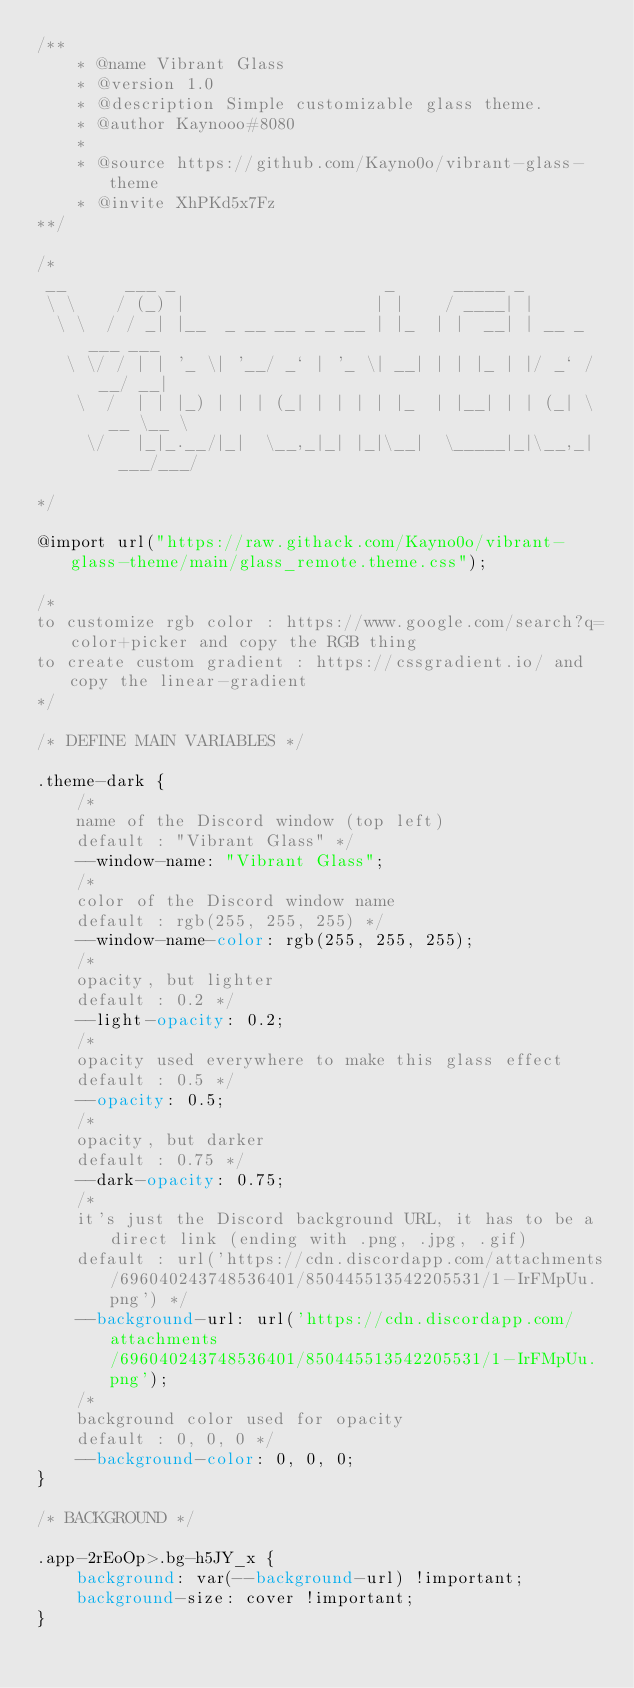<code> <loc_0><loc_0><loc_500><loc_500><_CSS_>/**
    * @name Vibrant Glass
    * @version 1.0
    * @description Simple customizable glass theme.
    * @author Kaynooo#8080
    *
    * @source https://github.com/Kayno0o/vibrant-glass-theme
    * @invite XhPKd5x7Fz
**/

/*
 __      ___ _                     _      _____ _               
 \ \    / (_) |                   | |    / ____| |              
  \ \  / / _| |__  _ __ __ _ _ __ | |_  | |  __| | __ _ ___ ___ 
   \ \/ / | | '_ \| '__/ _` | '_ \| __| | | |_ | |/ _` / __/ __|
    \  /  | | |_) | | | (_| | | | | |_  | |__| | | (_| \__ \__ \
     \/   |_|_.__/|_|  \__,_|_| |_|\__|  \_____|_|\__,_|___/___/

*/

@import url("https://raw.githack.com/Kayno0o/vibrant-glass-theme/main/glass_remote.theme.css");

/*
to customize rgb color : https://www.google.com/search?q=color+picker and copy the RGB thing
to create custom gradient : https://cssgradient.io/ and copy the linear-gradient
*/

/* DEFINE MAIN VARIABLES */

.theme-dark {
    /*
    name of the Discord window (top left)
    default : "Vibrant Glass" */
    --window-name: "Vibrant Glass";
    /*
    color of the Discord window name
    default : rgb(255, 255, 255) */
    --window-name-color: rgb(255, 255, 255);
    /*
    opacity, but lighter
    default : 0.2 */
    --light-opacity: 0.2;
    /*
    opacity used everywhere to make this glass effect 
    default : 0.5 */
    --opacity: 0.5;
    /*
    opacity, but darker
    default : 0.75 */
    --dark-opacity: 0.75;
    /*
    it's just the Discord background URL, it has to be a direct link (ending with .png, .jpg, .gif)
    default : url('https://cdn.discordapp.com/attachments/696040243748536401/850445513542205531/1-IrFMpUu.png') */
    --background-url: url('https://cdn.discordapp.com/attachments/696040243748536401/850445513542205531/1-IrFMpUu.png');
    /*
    background color used for opacity
    default : 0, 0, 0 */
    --background-color: 0, 0, 0;
}

/* BACKGROUND */

.app-2rEoOp>.bg-h5JY_x {
    background: var(--background-url) !important;
    background-size: cover !important;
}</code> 